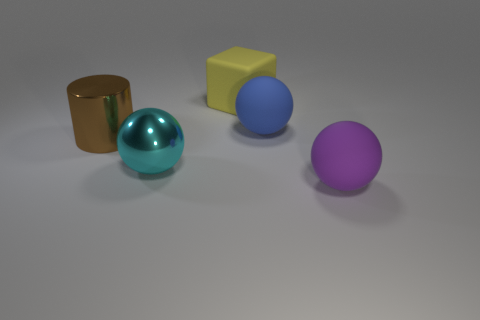Add 2 large cyan things. How many objects exist? 7 Subtract all balls. How many objects are left? 2 Subtract 0 cyan cubes. How many objects are left? 5 Subtract all large cyan matte objects. Subtract all big yellow objects. How many objects are left? 4 Add 5 large brown metallic things. How many large brown metallic things are left? 6 Add 1 brown objects. How many brown objects exist? 2 